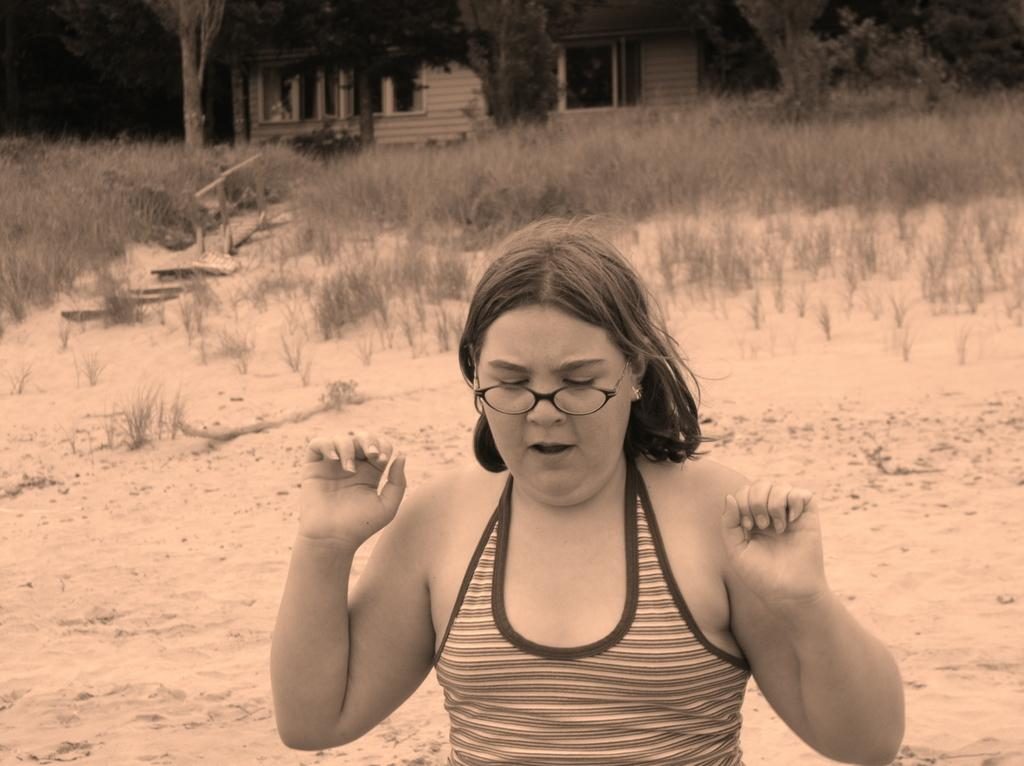Who is the main subject in the image? There is a woman in the image. What is at the bottom of the image? There is ground at the bottom of the image. What type of vegetation can be seen on the ground in the image? There are plants on the ground in the image. What can be seen in the background of the image? There are trees in the background of the image. What type of condition does the woman's haircut have in the image? There is no information about the woman's haircut in the image, so it cannot be determined. 